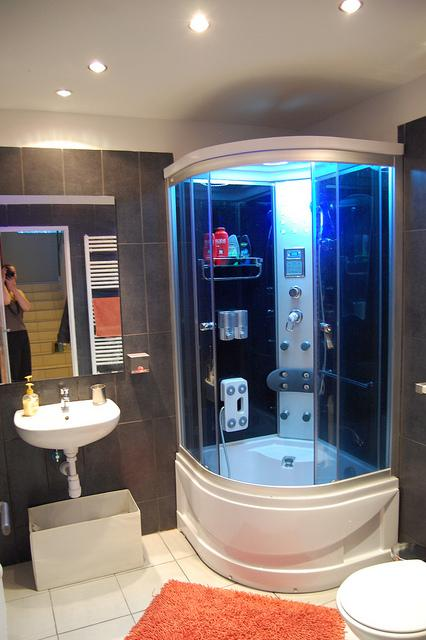What might a person do inside the blue lit area? take shower 